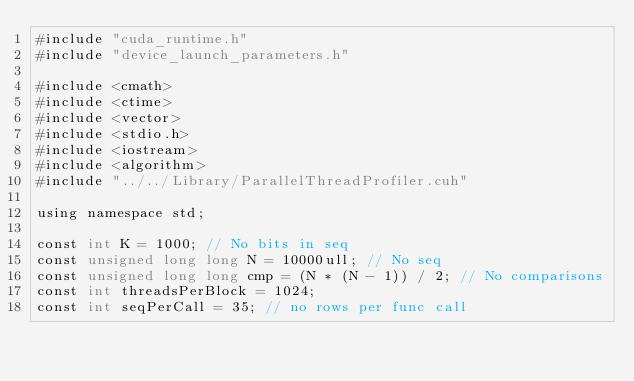Convert code to text. <code><loc_0><loc_0><loc_500><loc_500><_Cuda_>#include "cuda_runtime.h"
#include "device_launch_parameters.h"

#include <cmath>
#include <ctime>
#include <vector>
#include <stdio.h>
#include <iostream>
#include <algorithm>
#include "../../Library/ParallelThreadProfiler.cuh"

using namespace std;

const int K = 1000; // No bits in seq
const unsigned long long N = 10000ull; // No seq
const unsigned long long cmp = (N * (N - 1)) / 2; // No comparisons
const int threadsPerBlock = 1024;
const int seqPerCall = 35; // no rows per func call</code> 